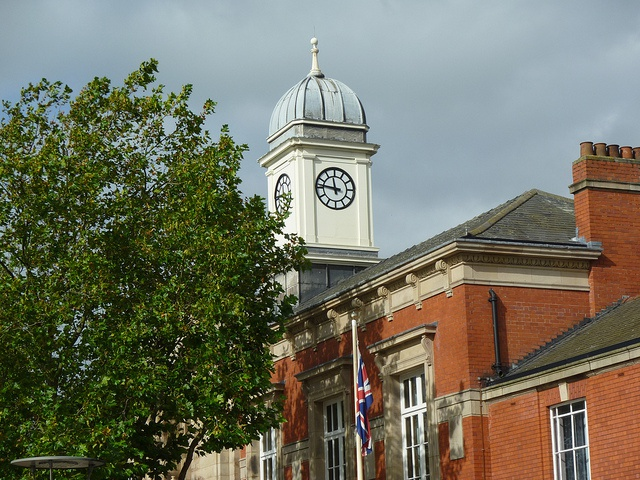Describe the objects in this image and their specific colors. I can see clock in darkgray, lightgray, and black tones and clock in darkgray, white, gray, and black tones in this image. 